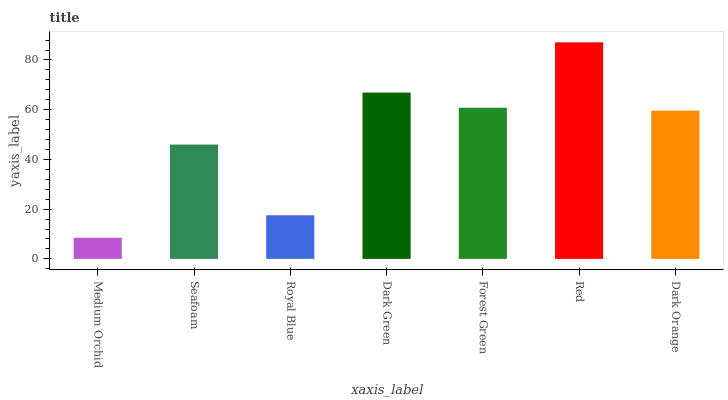Is Medium Orchid the minimum?
Answer yes or no. Yes. Is Red the maximum?
Answer yes or no. Yes. Is Seafoam the minimum?
Answer yes or no. No. Is Seafoam the maximum?
Answer yes or no. No. Is Seafoam greater than Medium Orchid?
Answer yes or no. Yes. Is Medium Orchid less than Seafoam?
Answer yes or no. Yes. Is Medium Orchid greater than Seafoam?
Answer yes or no. No. Is Seafoam less than Medium Orchid?
Answer yes or no. No. Is Dark Orange the high median?
Answer yes or no. Yes. Is Dark Orange the low median?
Answer yes or no. Yes. Is Forest Green the high median?
Answer yes or no. No. Is Red the low median?
Answer yes or no. No. 